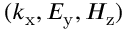Convert formula to latex. <formula><loc_0><loc_0><loc_500><loc_500>( k _ { x } , E _ { y } , H _ { z } )</formula> 